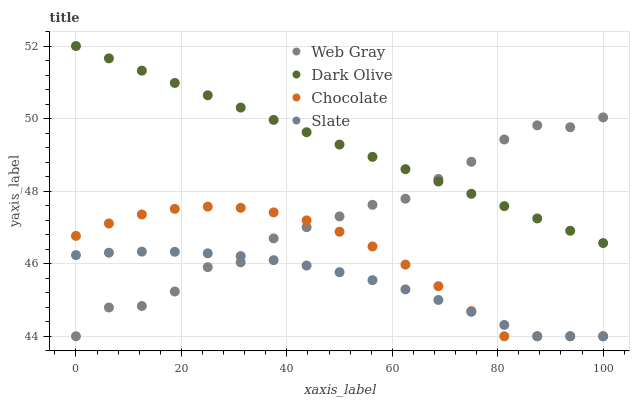Does Slate have the minimum area under the curve?
Answer yes or no. Yes. Does Dark Olive have the maximum area under the curve?
Answer yes or no. Yes. Does Web Gray have the minimum area under the curve?
Answer yes or no. No. Does Web Gray have the maximum area under the curve?
Answer yes or no. No. Is Dark Olive the smoothest?
Answer yes or no. Yes. Is Web Gray the roughest?
Answer yes or no. Yes. Is Slate the smoothest?
Answer yes or no. No. Is Slate the roughest?
Answer yes or no. No. Does Slate have the lowest value?
Answer yes or no. Yes. Does Dark Olive have the highest value?
Answer yes or no. Yes. Does Web Gray have the highest value?
Answer yes or no. No. Is Chocolate less than Dark Olive?
Answer yes or no. Yes. Is Dark Olive greater than Chocolate?
Answer yes or no. Yes. Does Web Gray intersect Dark Olive?
Answer yes or no. Yes. Is Web Gray less than Dark Olive?
Answer yes or no. No. Is Web Gray greater than Dark Olive?
Answer yes or no. No. Does Chocolate intersect Dark Olive?
Answer yes or no. No. 